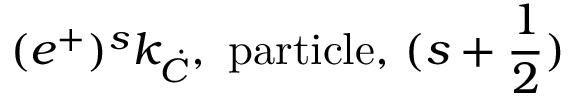Convert formula to latex. <formula><loc_0><loc_0><loc_500><loc_500>( e ^ { + } ) ^ { s } k _ { \dot { C } } , p a r t i c l e , ( s + \frac { 1 } { 2 } )</formula> 